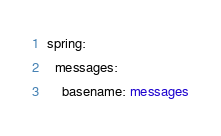Convert code to text. <code><loc_0><loc_0><loc_500><loc_500><_YAML_>spring:
  messages:
    basename: messages</code> 